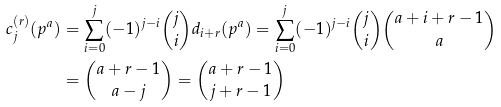<formula> <loc_0><loc_0><loc_500><loc_500>c ^ { ( r ) } _ { j } ( p ^ { a } ) & = \sum _ { i = 0 } ^ { j } ( - 1 ) ^ { j - i } { j \choose i } d _ { i + r } ( p ^ { a } ) = \sum _ { i = 0 } ^ { j } ( - 1 ) ^ { j - i } { j \choose i } { a + i + r - 1 \choose a } \\ & = { a + r - 1 \choose a - j } = { a + r - 1 \choose j + r - 1 }</formula> 